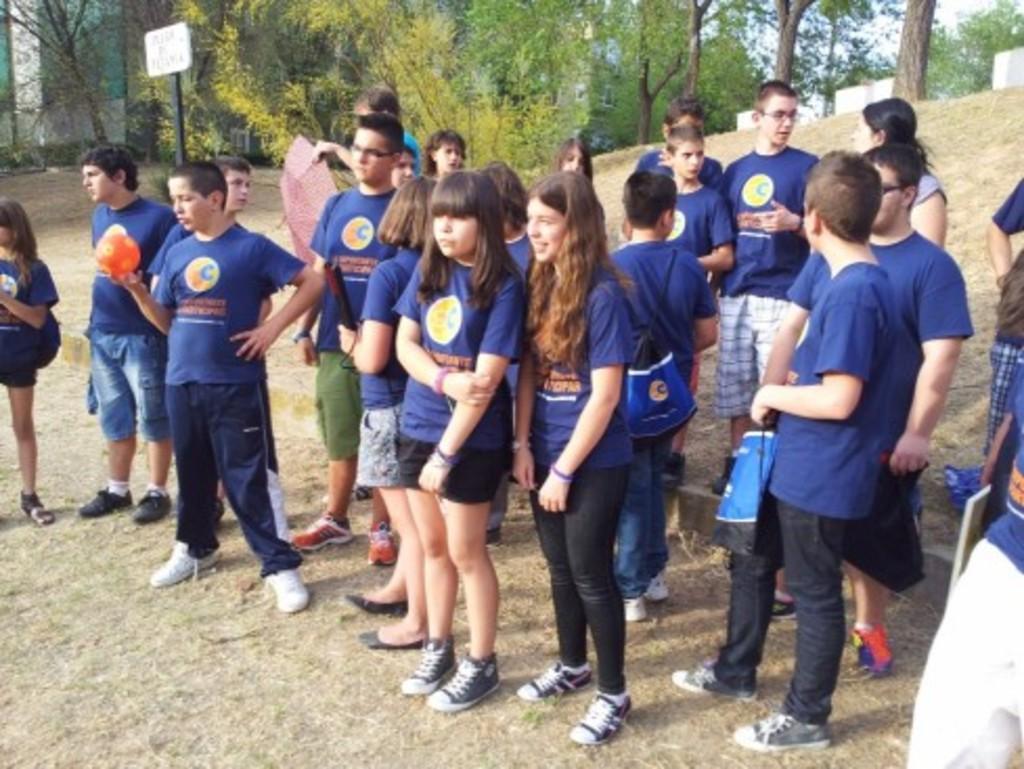In one or two sentences, can you explain what this image depicts? In this picture we can see a group of people standing on the ground, bags, umbrella, name board, some objects and in the background we can see trees. 